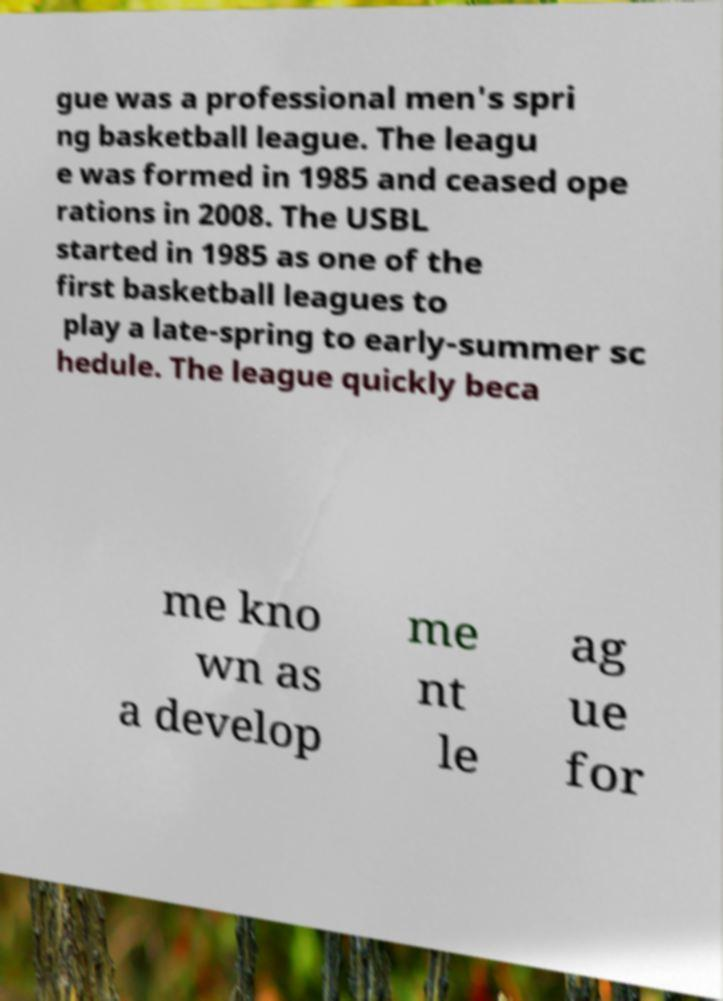Could you extract and type out the text from this image? gue was a professional men's spri ng basketball league. The leagu e was formed in 1985 and ceased ope rations in 2008. The USBL started in 1985 as one of the first basketball leagues to play a late-spring to early-summer sc hedule. The league quickly beca me kno wn as a develop me nt le ag ue for 